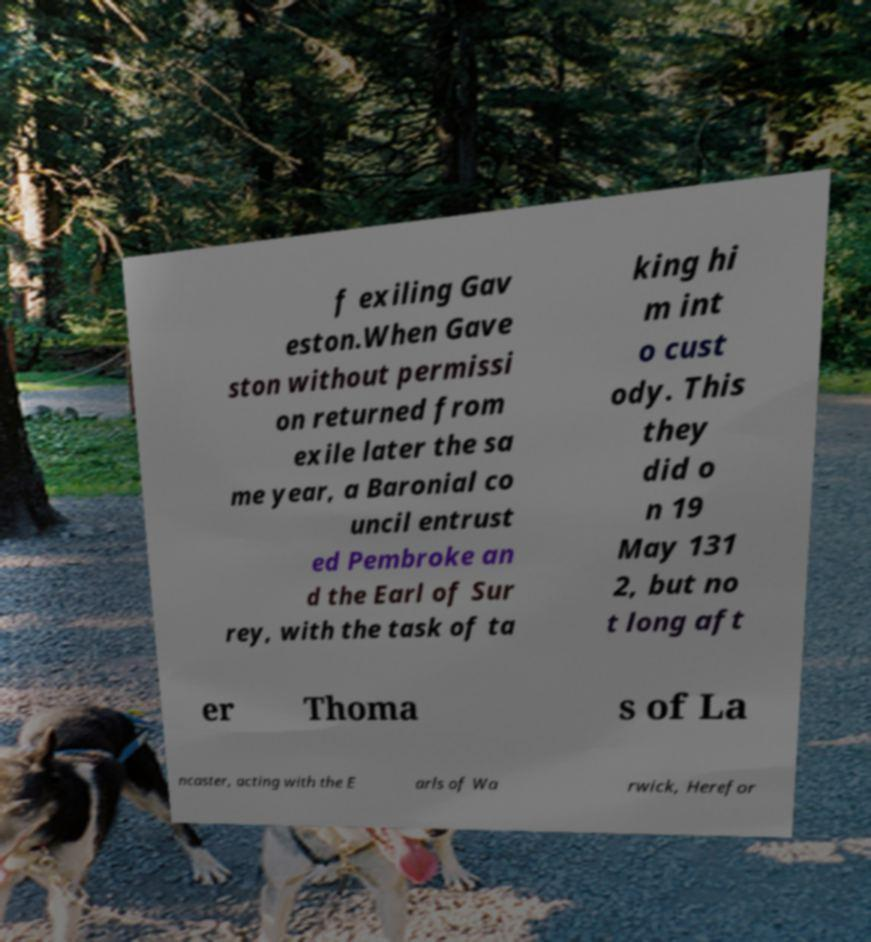Could you extract and type out the text from this image? f exiling Gav eston.When Gave ston without permissi on returned from exile later the sa me year, a Baronial co uncil entrust ed Pembroke an d the Earl of Sur rey, with the task of ta king hi m int o cust ody. This they did o n 19 May 131 2, but no t long aft er Thoma s of La ncaster, acting with the E arls of Wa rwick, Herefor 